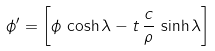<formula> <loc_0><loc_0><loc_500><loc_500>\phi ^ { \prime } = \left [ \phi \, \cosh { \lambda } - t \, \frac { c } { \rho } \, \sinh { \lambda } \right ]</formula> 